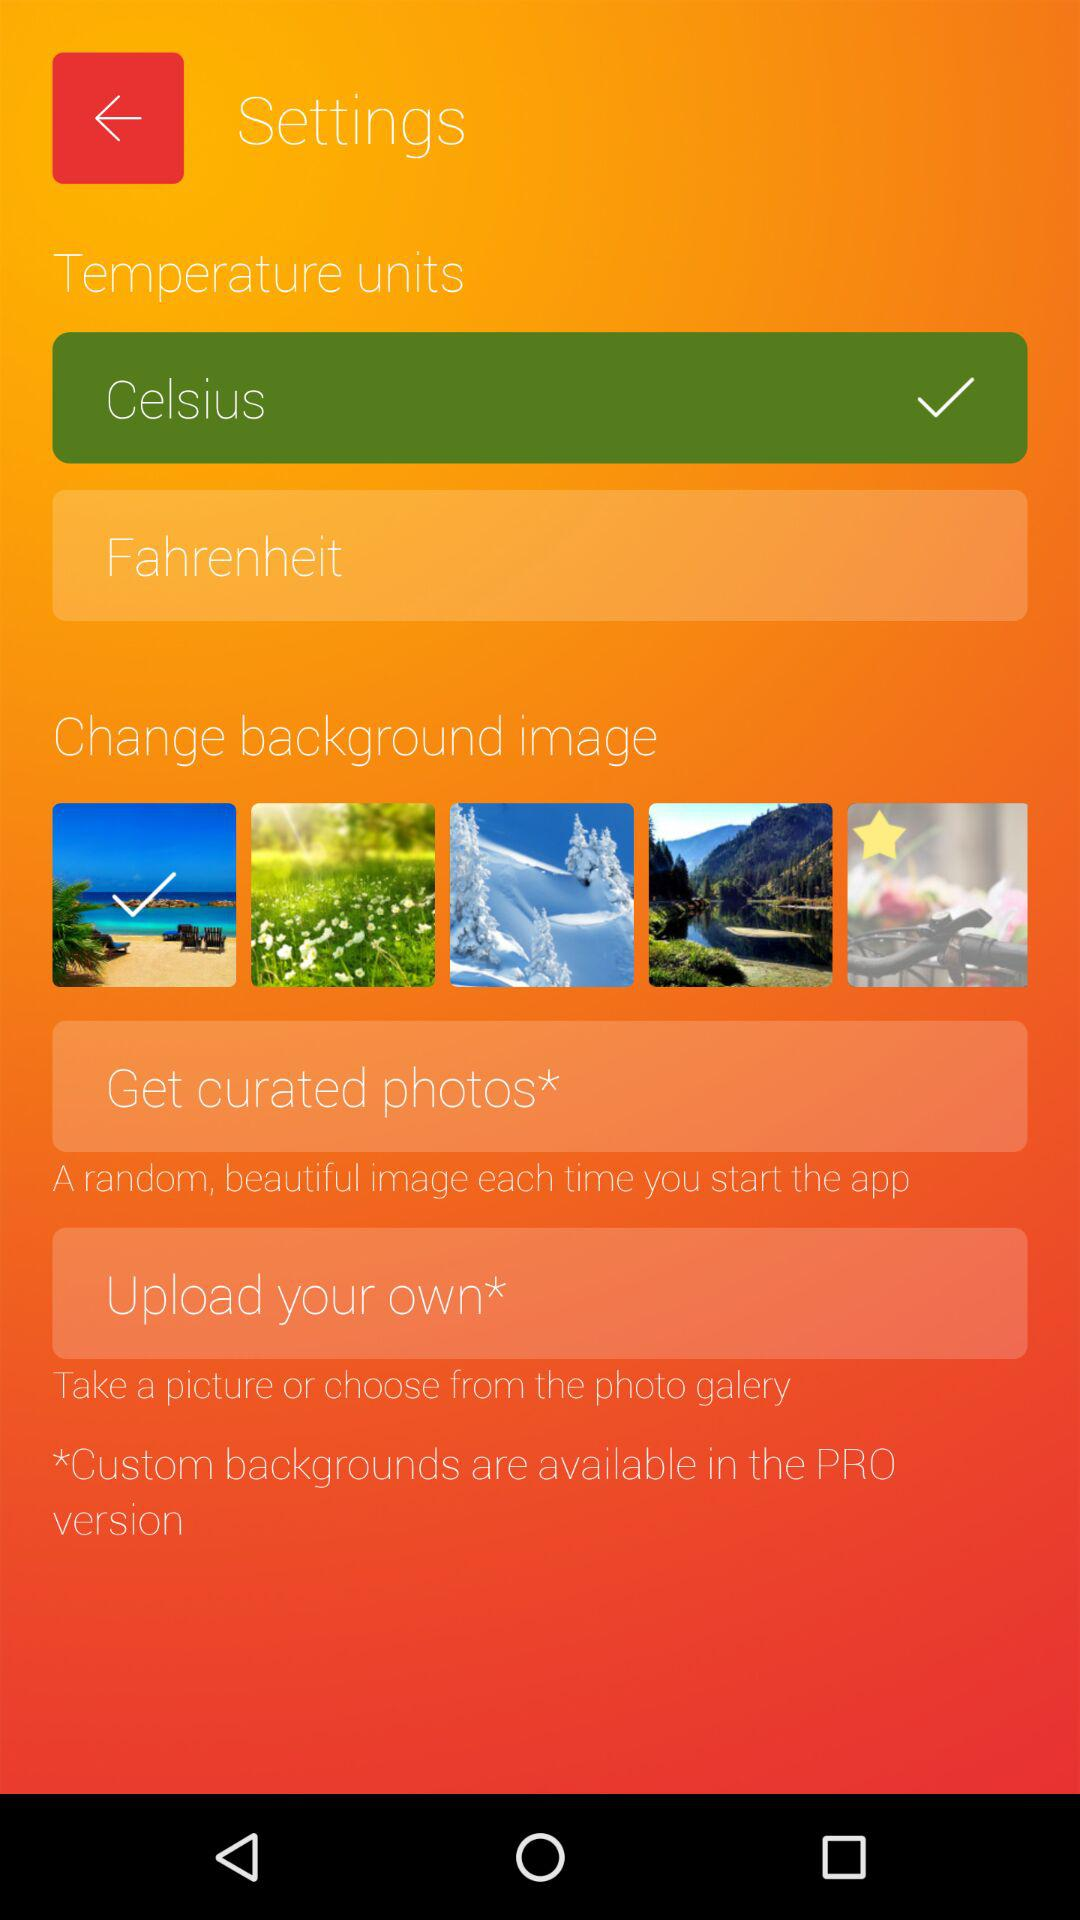What is the temperature unit set to? The temperature unit is set to Celsius. 